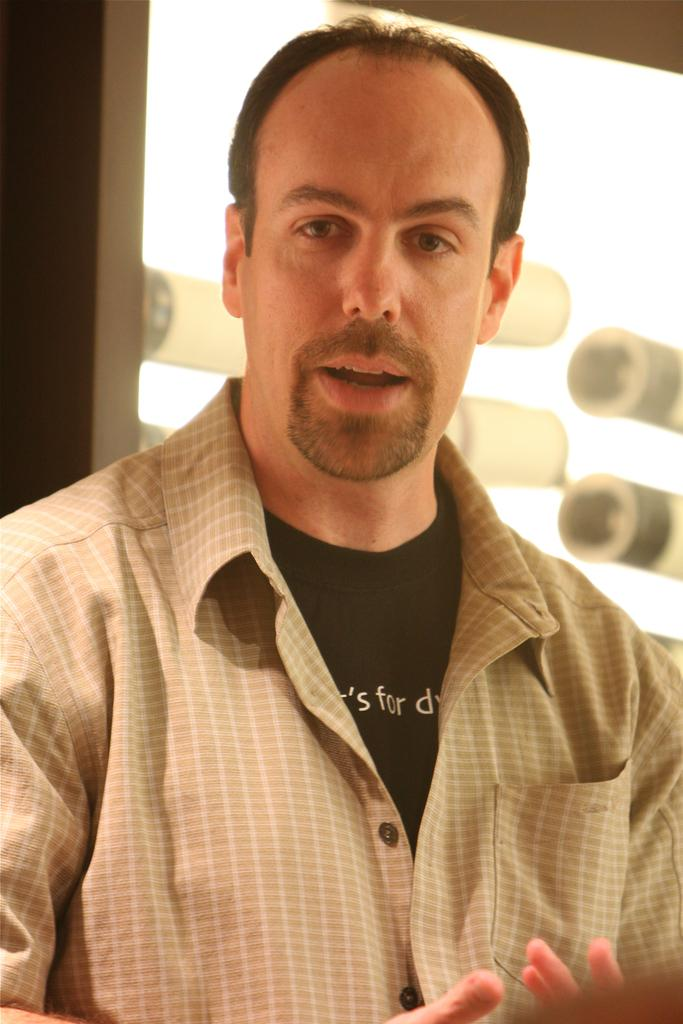What is the main subject of the image? There is a man in the image. What is the man wearing? The man is wearing a checked shirt and a black shirt. Can you describe the lighting in the image? There is light behind the man. What type of sail can be seen in the image? There is no sail present in the image. Is the man's uncle visible in the image? The facts provided do not mention the man's uncle, so we cannot determine if he is present in the image. 